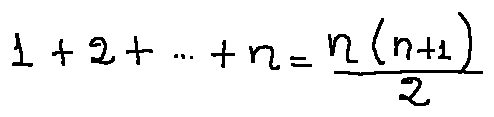<formula> <loc_0><loc_0><loc_500><loc_500>1 + 2 + \cdots + n = \frac { n ( n + 1 ) } { 2 }</formula> 